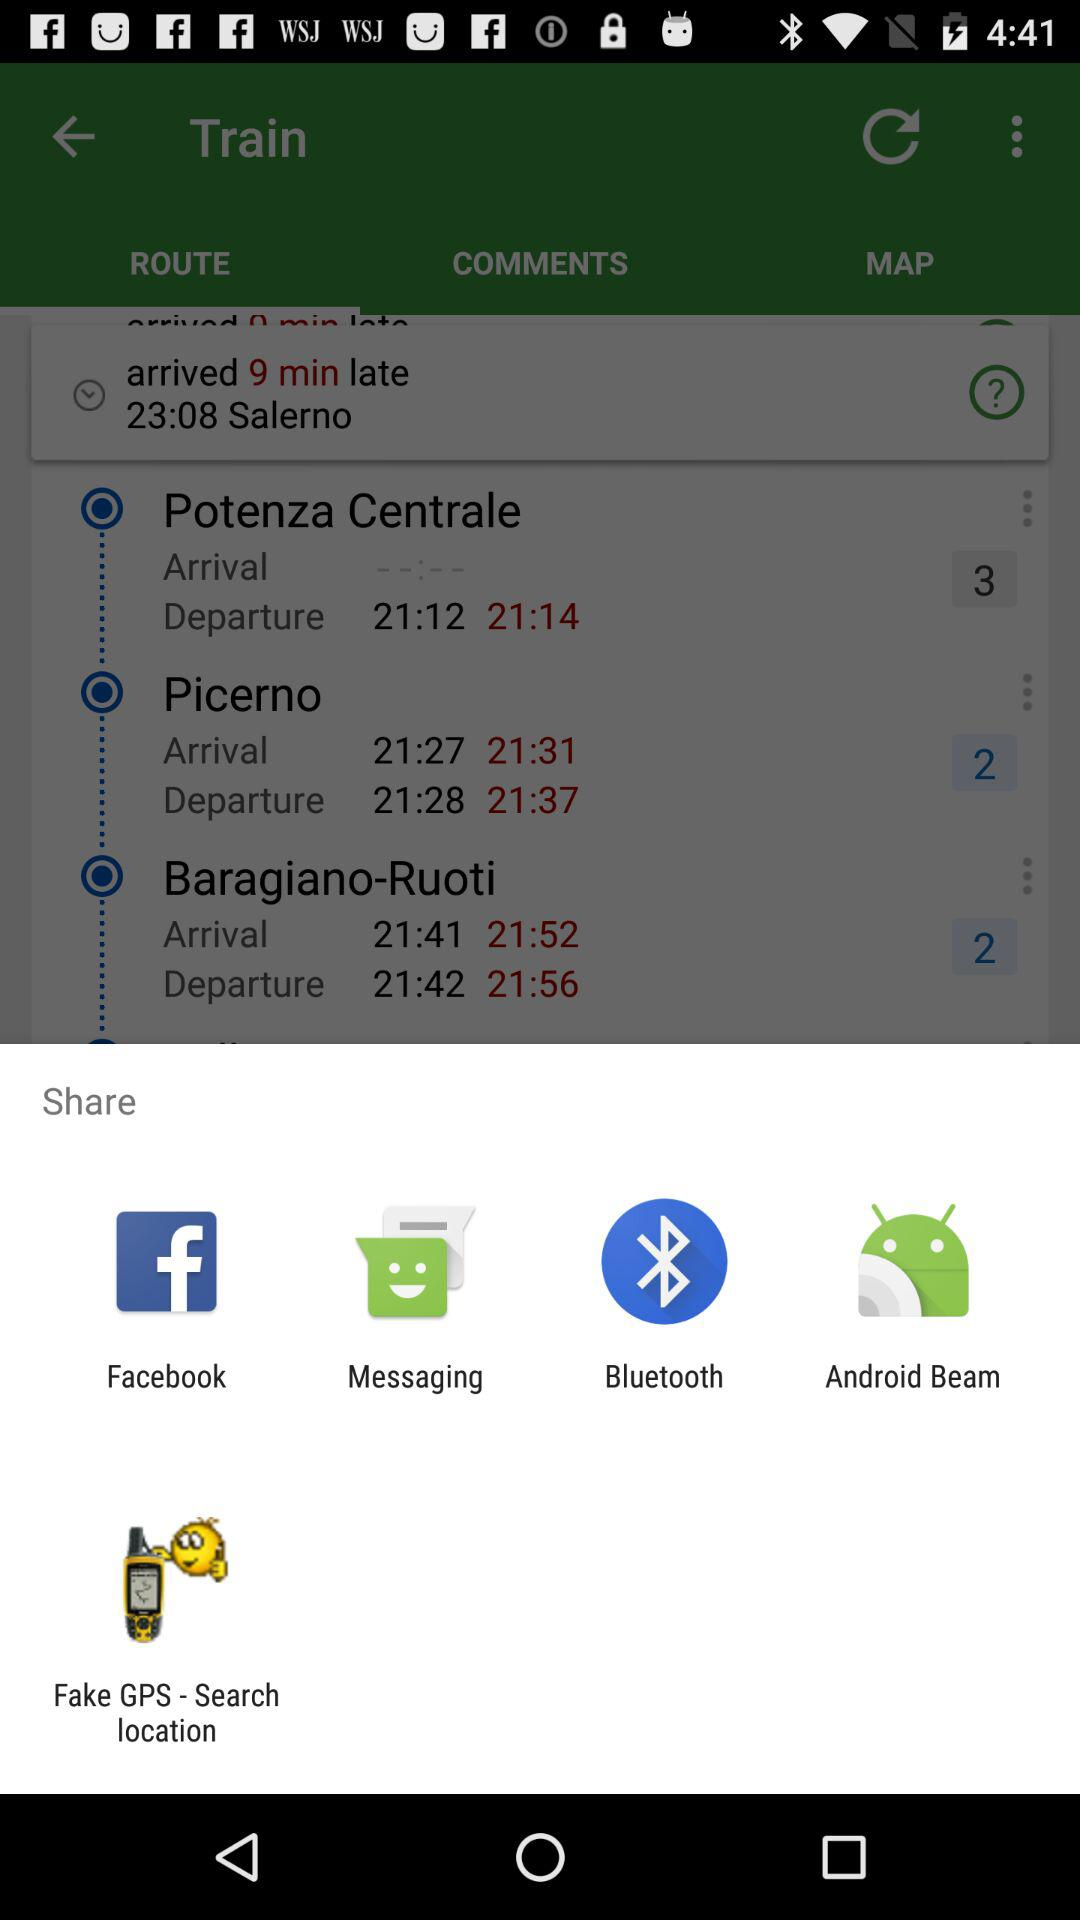How many stops are there on this trip?
Answer the question using a single word or phrase. 3 